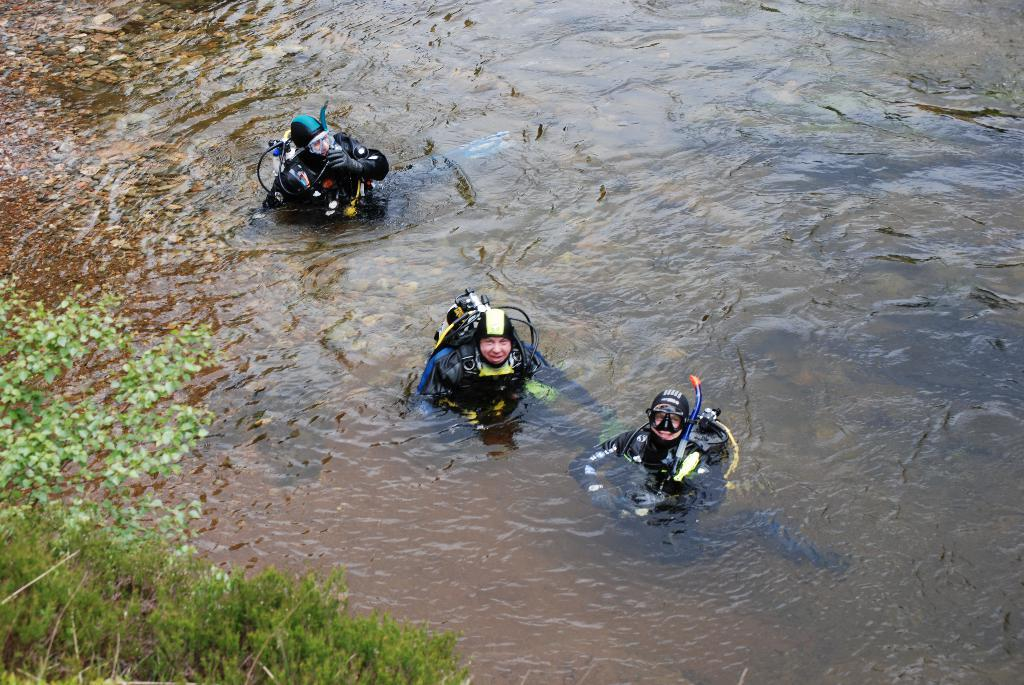What are the people in the image doing? The people in the image are in a water body. What else can be seen in the image besides the people? There are plants visible in the image. What type of nail can be seen in the image? There is no nail present in the image. How old is the boy in the image? There is no boy present in the image. 